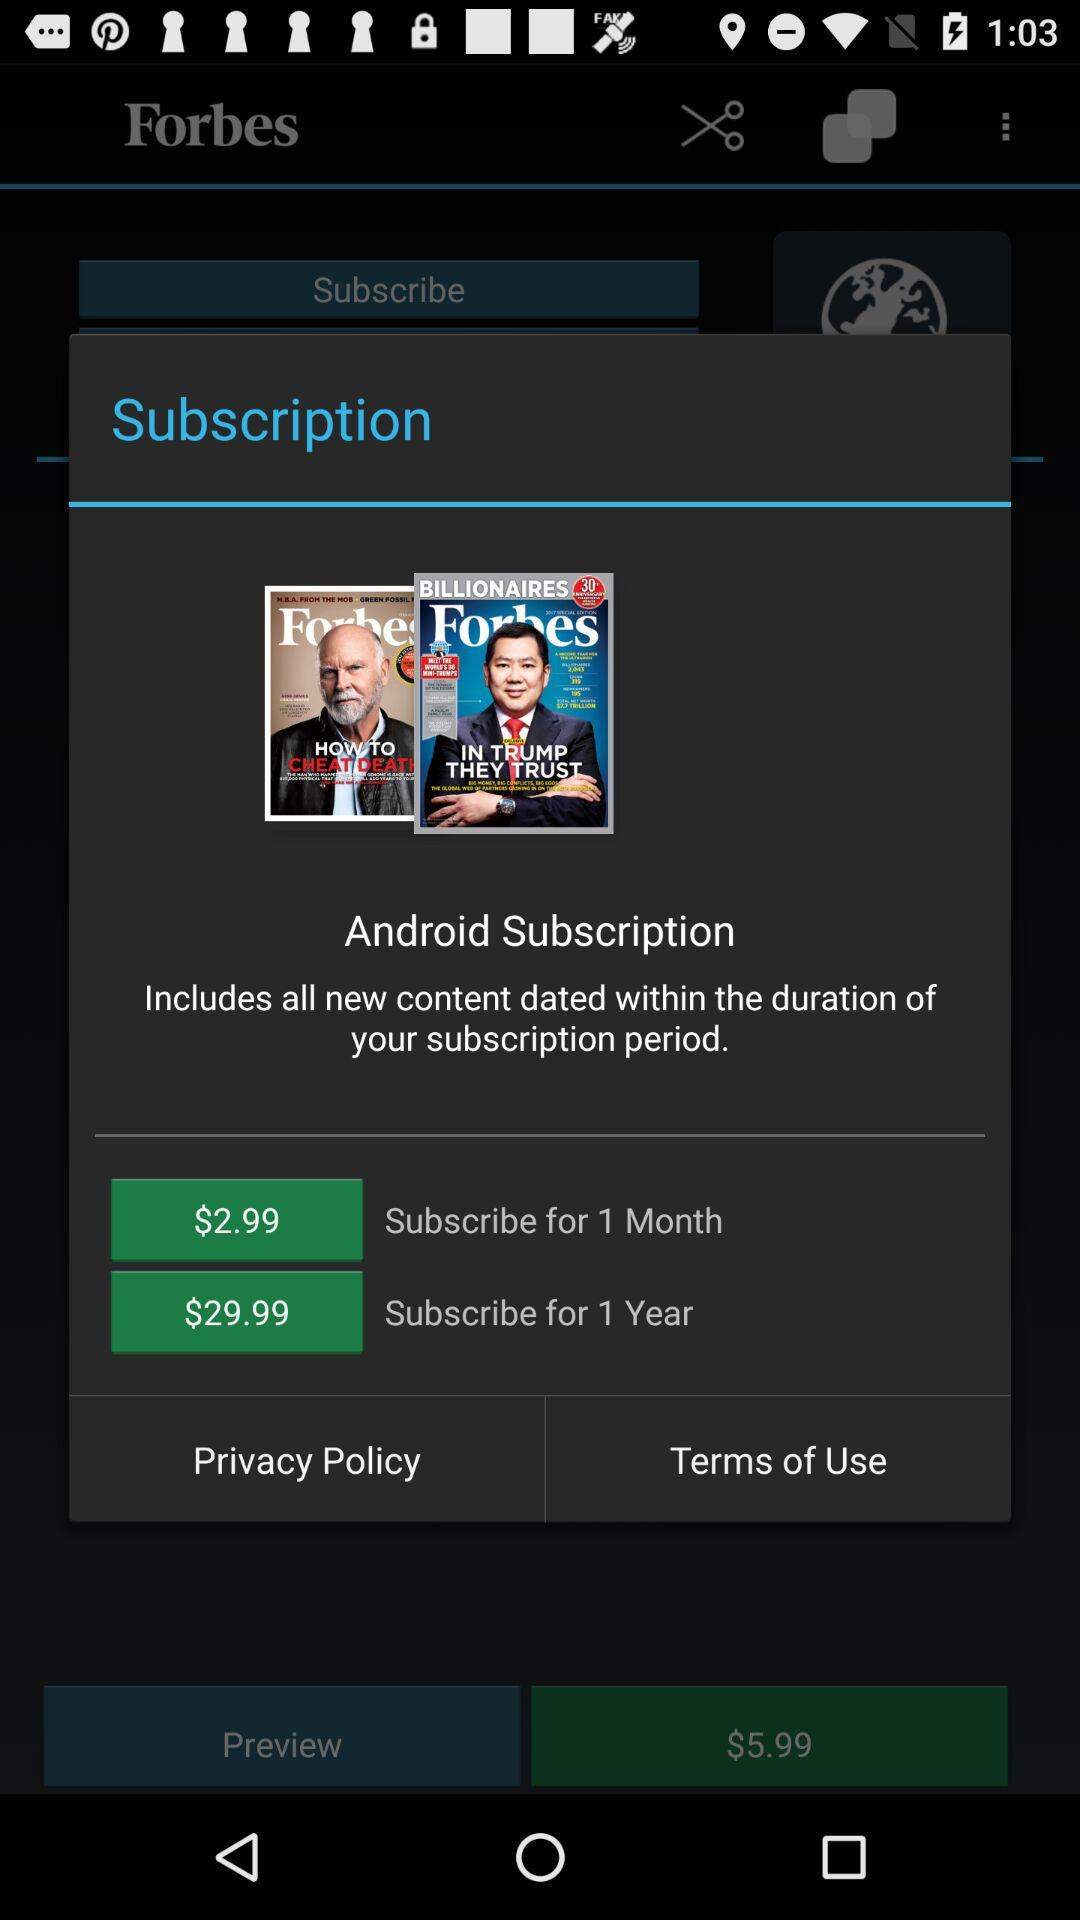What is the currency of price? The currency is $. 